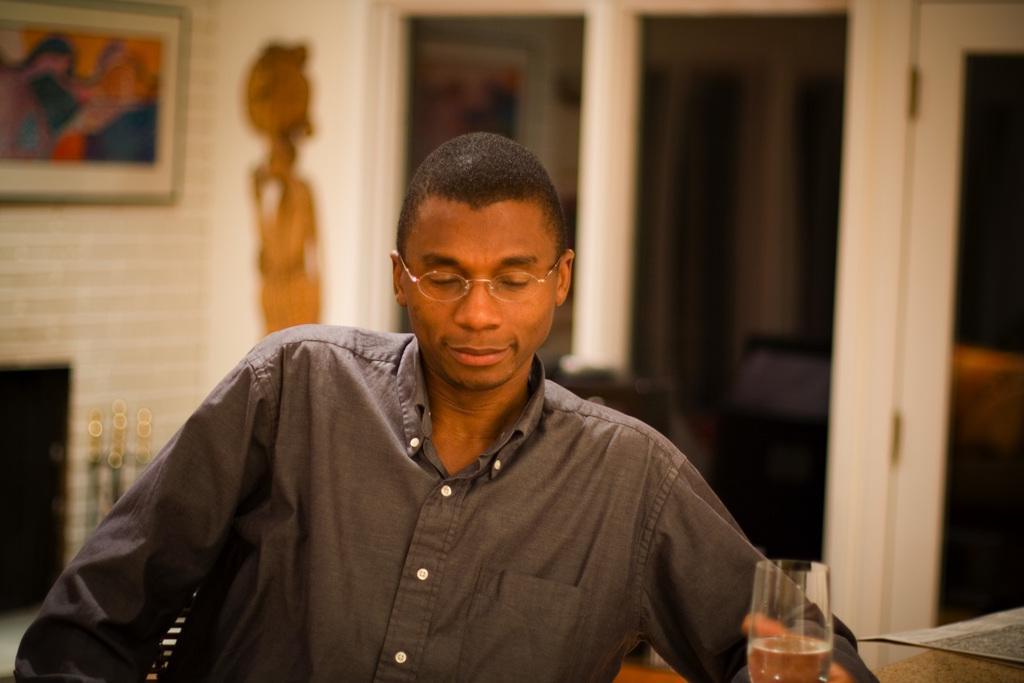Could you give a brief overview of what you see in this image? In this image I can see a man, there is a glass in the front. The background is blurred. 